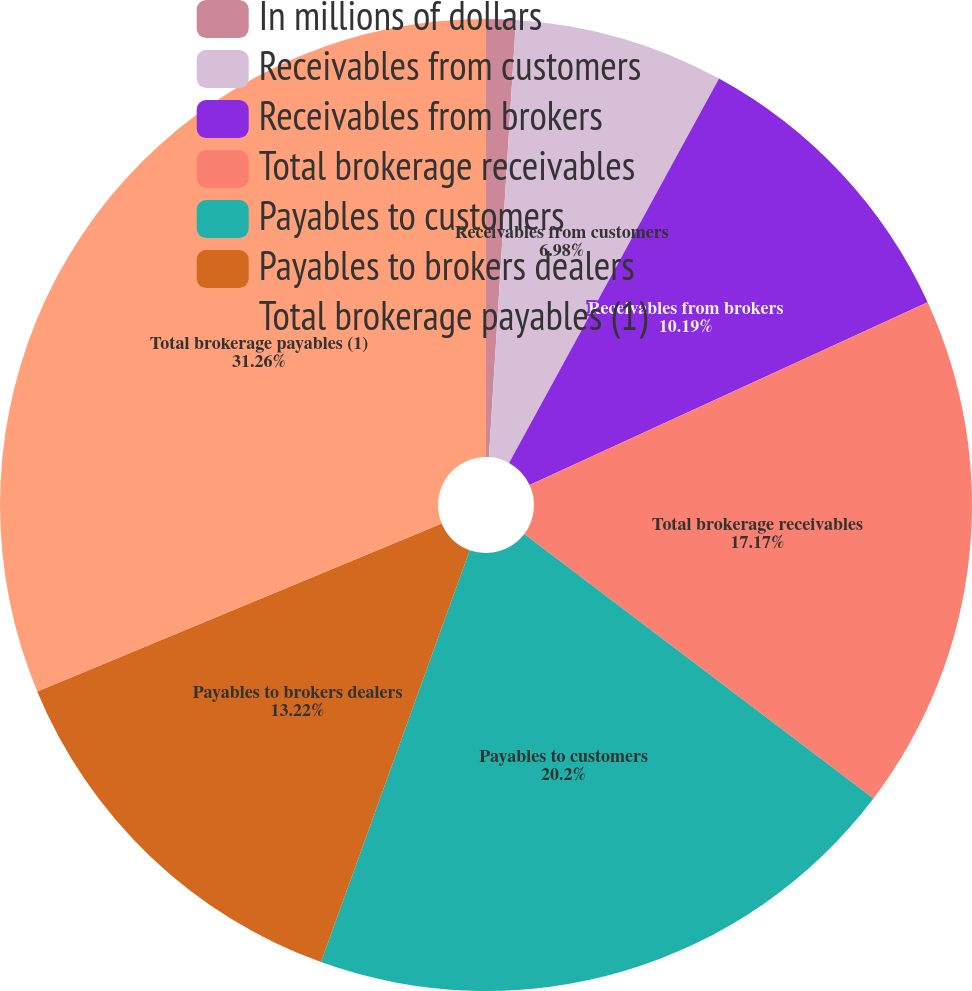Convert chart to OTSL. <chart><loc_0><loc_0><loc_500><loc_500><pie_chart><fcel>In millions of dollars<fcel>Receivables from customers<fcel>Receivables from brokers<fcel>Total brokerage receivables<fcel>Payables to customers<fcel>Payables to brokers dealers<fcel>Total brokerage payables (1)<nl><fcel>0.98%<fcel>6.98%<fcel>10.19%<fcel>17.17%<fcel>20.2%<fcel>13.22%<fcel>31.27%<nl></chart> 